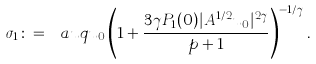<formula> <loc_0><loc_0><loc_500><loc_500>\sigma _ { 1 } \colon = \ a u q { u _ { 0 } } \left ( 1 + \frac { 3 \gamma P _ { 1 } ( 0 ) | A ^ { 1 / 2 } u _ { 0 } | ^ { 2 \gamma } } { p + 1 } \right ) ^ { - 1 / \gamma } .</formula> 